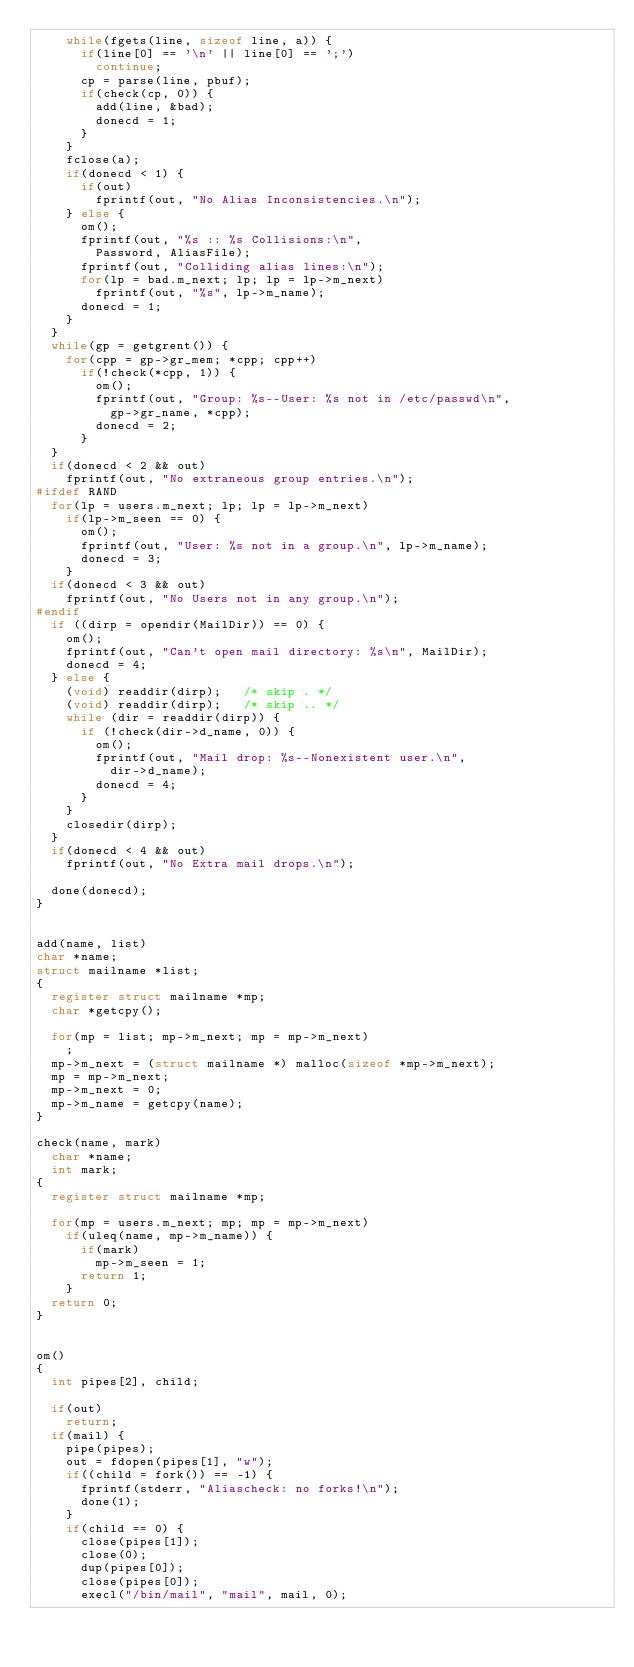Convert code to text. <code><loc_0><loc_0><loc_500><loc_500><_C_>		while(fgets(line, sizeof line, a)) {
			if(line[0] == '\n' || line[0] == ';')
				continue;
			cp = parse(line, pbuf);
			if(check(cp, 0)) {
				add(line, &bad);
				donecd = 1;
			}
		}
		fclose(a);
		if(donecd < 1) {
			if(out)
				fprintf(out, "No Alias Inconsistencies.\n");
		} else {
			om();
			fprintf(out, "%s :: %s Collisions:\n",
				Password, AliasFile);
			fprintf(out, "Colliding alias lines:\n");
			for(lp = bad.m_next; lp; lp = lp->m_next)
				fprintf(out, "%s", lp->m_name);
			donecd = 1;
		}
	}
	while(gp = getgrent()) {
		for(cpp = gp->gr_mem; *cpp; cpp++)
			if(!check(*cpp, 1)) {
				om();
				fprintf(out, "Group: %s--User: %s not in /etc/passwd\n",
					gp->gr_name, *cpp);
				donecd = 2;
			}
	}
	if(donecd < 2 && out)
		fprintf(out, "No extraneous group entries.\n");
#ifdef RAND
	for(lp = users.m_next; lp; lp = lp->m_next)
		if(lp->m_seen == 0) {
			om();
			fprintf(out, "User: %s not in a group.\n", lp->m_name);
			donecd = 3;
		}
	if(donecd < 3 && out)
		fprintf(out, "No Users not in any group.\n");
#endif
	if ((dirp = opendir(MailDir)) == 0) {
		om();
		fprintf(out, "Can't open mail directory: %s\n", MailDir);
		donecd = 4;
	} else {
		(void) readdir(dirp);		/* skip . */
		(void) readdir(dirp);		/* skip .. */
		while (dir = readdir(dirp)) {
			if (!check(dir->d_name, 0)) {
				om();
				fprintf(out, "Mail drop: %s--Nonexistent user.\n",
					dir->d_name);
				donecd = 4;
			}
		}
		closedir(dirp);
	}
	if(donecd < 4 && out)
		fprintf(out, "No Extra mail drops.\n");

	done(donecd);
}


add(name, list)
char *name;
struct mailname *list;
{
	register struct mailname *mp;
	char *getcpy();

	for(mp = list; mp->m_next; mp = mp->m_next)
		;
	mp->m_next = (struct mailname *) malloc(sizeof *mp->m_next);
	mp = mp->m_next;
	mp->m_next = 0;
	mp->m_name = getcpy(name);
}

check(name, mark)
	char *name;
	int mark;
{
	register struct mailname *mp;

	for(mp = users.m_next; mp; mp = mp->m_next)
		if(uleq(name, mp->m_name)) {
			if(mark)
				mp->m_seen = 1;
			return 1;
		}
	return 0;
}


om()
{
	int pipes[2], child;

	if(out)
		return;
	if(mail) {
		pipe(pipes);
		out = fdopen(pipes[1], "w");
		if((child = fork()) == -1) {
			fprintf(stderr, "Aliascheck: no forks!\n");
			done(1);
		}
		if(child == 0) {
			close(pipes[1]);
			close(0);
			dup(pipes[0]);
			close(pipes[0]);
			execl("/bin/mail", "mail", mail, 0);</code> 